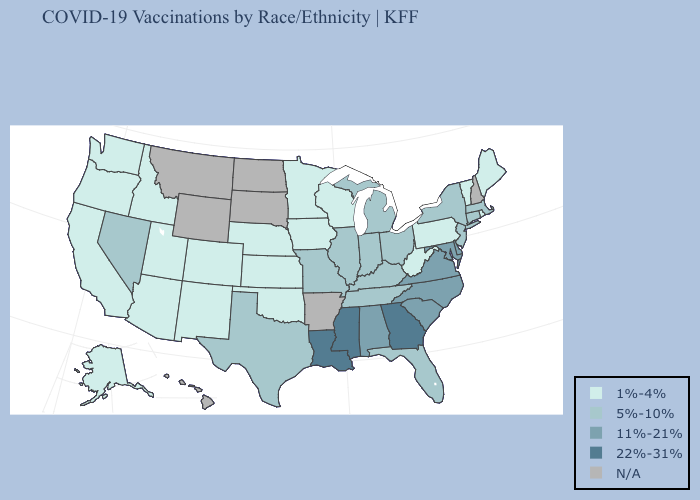Among the states that border Iowa , does Missouri have the highest value?
Keep it brief. Yes. What is the highest value in the USA?
Keep it brief. 22%-31%. Does Kentucky have the highest value in the USA?
Quick response, please. No. Does Indiana have the lowest value in the MidWest?
Be succinct. No. How many symbols are there in the legend?
Write a very short answer. 5. What is the value of New Mexico?
Write a very short answer. 1%-4%. Name the states that have a value in the range 11%-21%?
Answer briefly. Alabama, Delaware, Maryland, North Carolina, South Carolina, Virginia. What is the highest value in states that border Arizona?
Answer briefly. 5%-10%. Does Indiana have the lowest value in the USA?
Give a very brief answer. No. How many symbols are there in the legend?
Short answer required. 5. What is the lowest value in the MidWest?
Keep it brief. 1%-4%. Does Mississippi have the highest value in the USA?
Write a very short answer. Yes. What is the highest value in the South ?
Keep it brief. 22%-31%. What is the lowest value in states that border Oregon?
Quick response, please. 1%-4%. What is the value of Vermont?
Concise answer only. 1%-4%. 